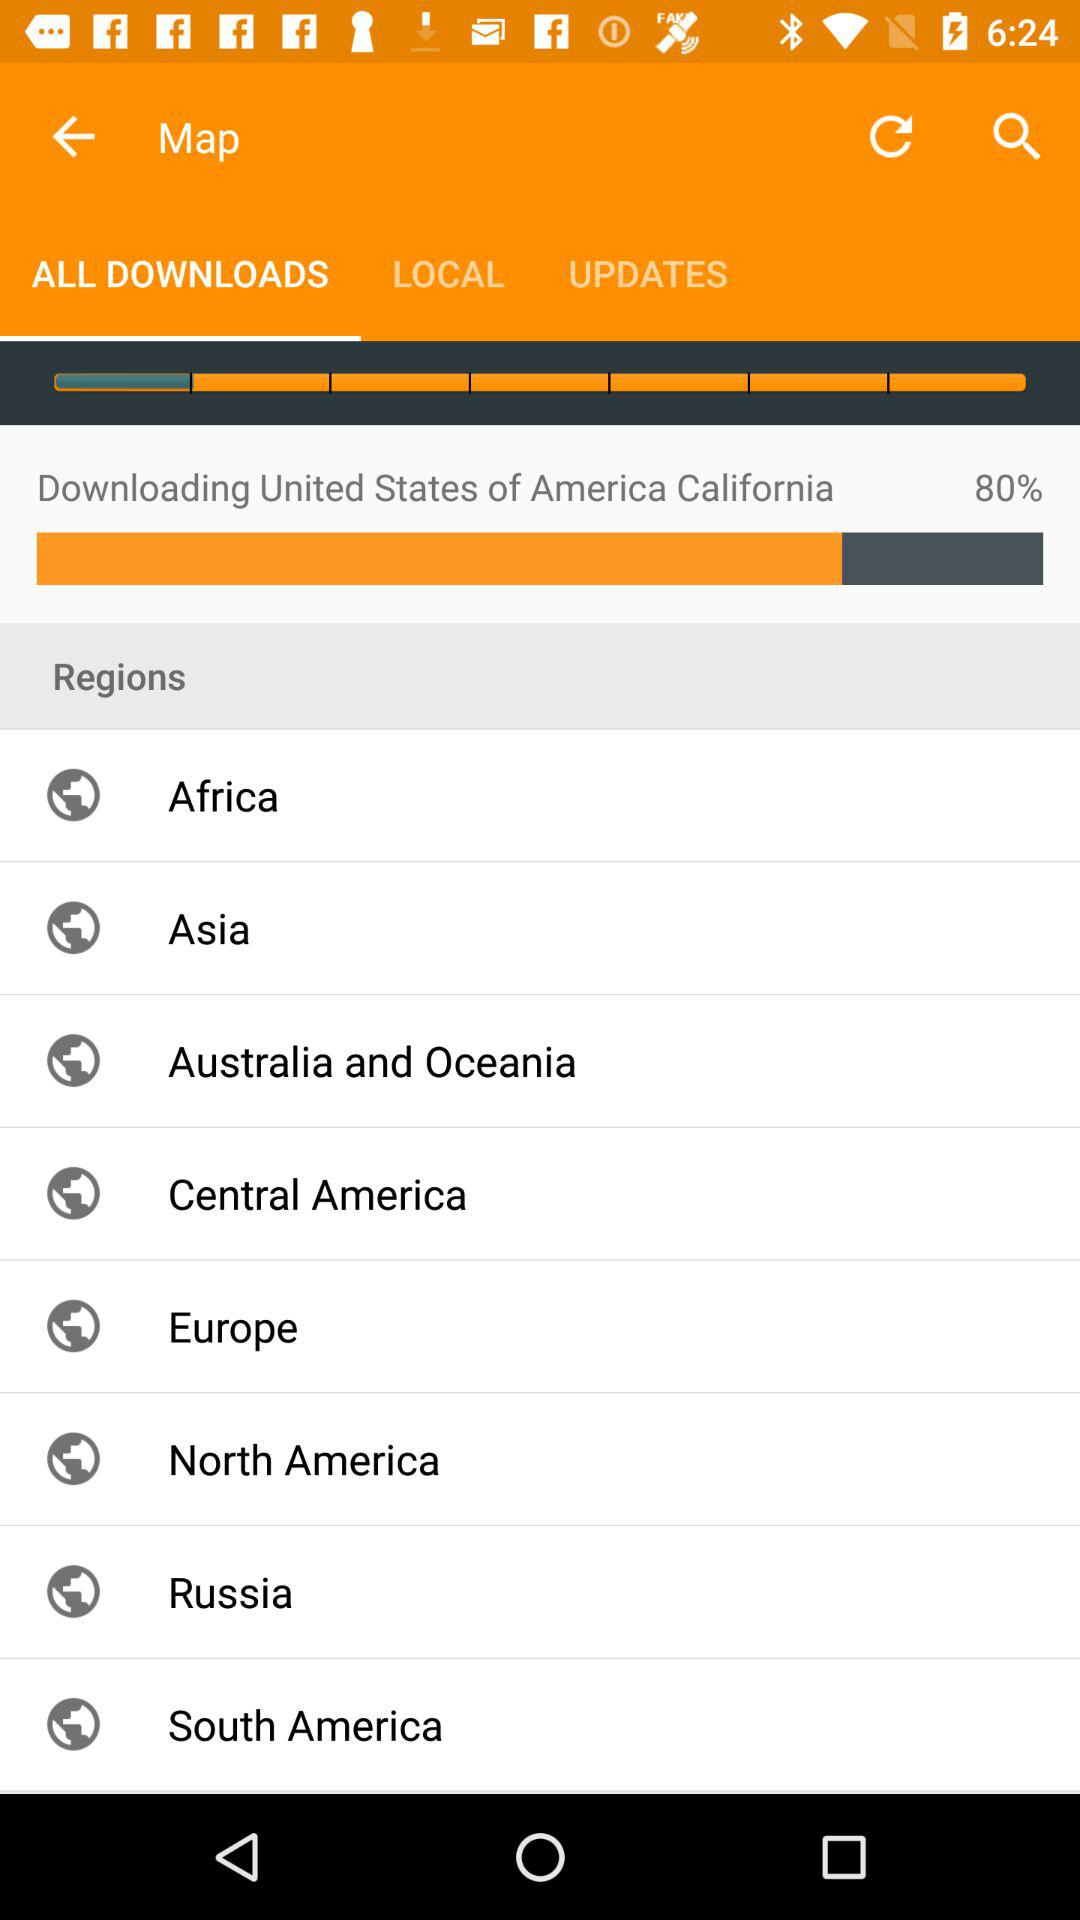What percentage of the map of the United States of America has been downloaded? The downloaded percentage is 80. 